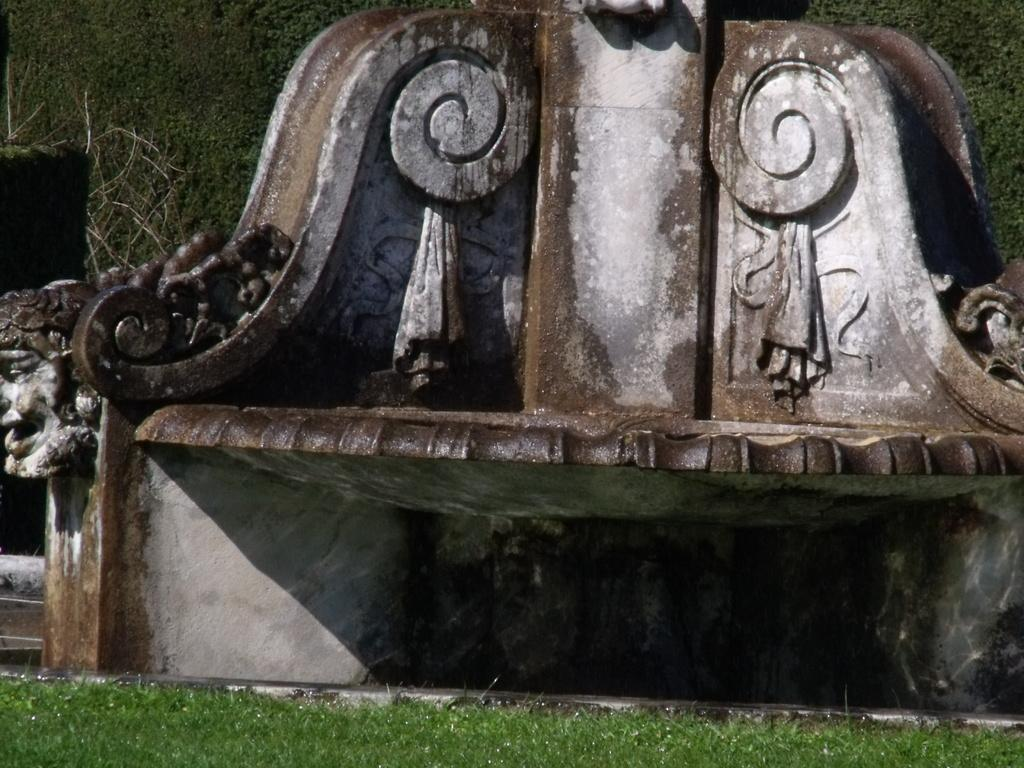What is depicted on the stone in the image? There is a carving on a stone in the image. What type of natural environment is visible in the image? There is grass visible in the image. What can be seen in the background of the image? There are plants in the background of the image. What type of spoon is being used by the ghost in the image? There is no spoon or ghost present in the image. 